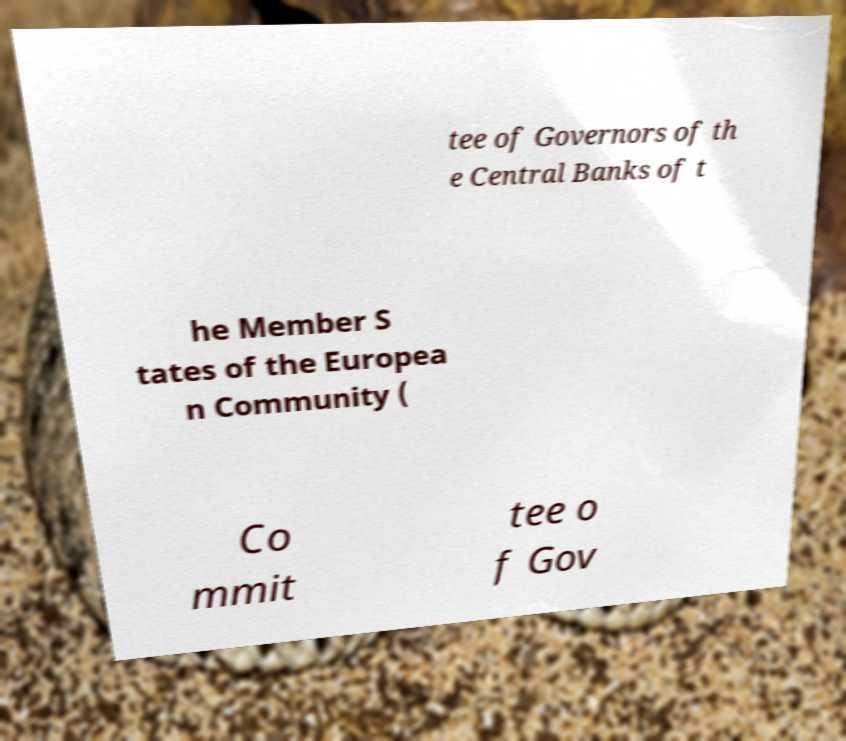There's text embedded in this image that I need extracted. Can you transcribe it verbatim? tee of Governors of th e Central Banks of t he Member S tates of the Europea n Community ( Co mmit tee o f Gov 